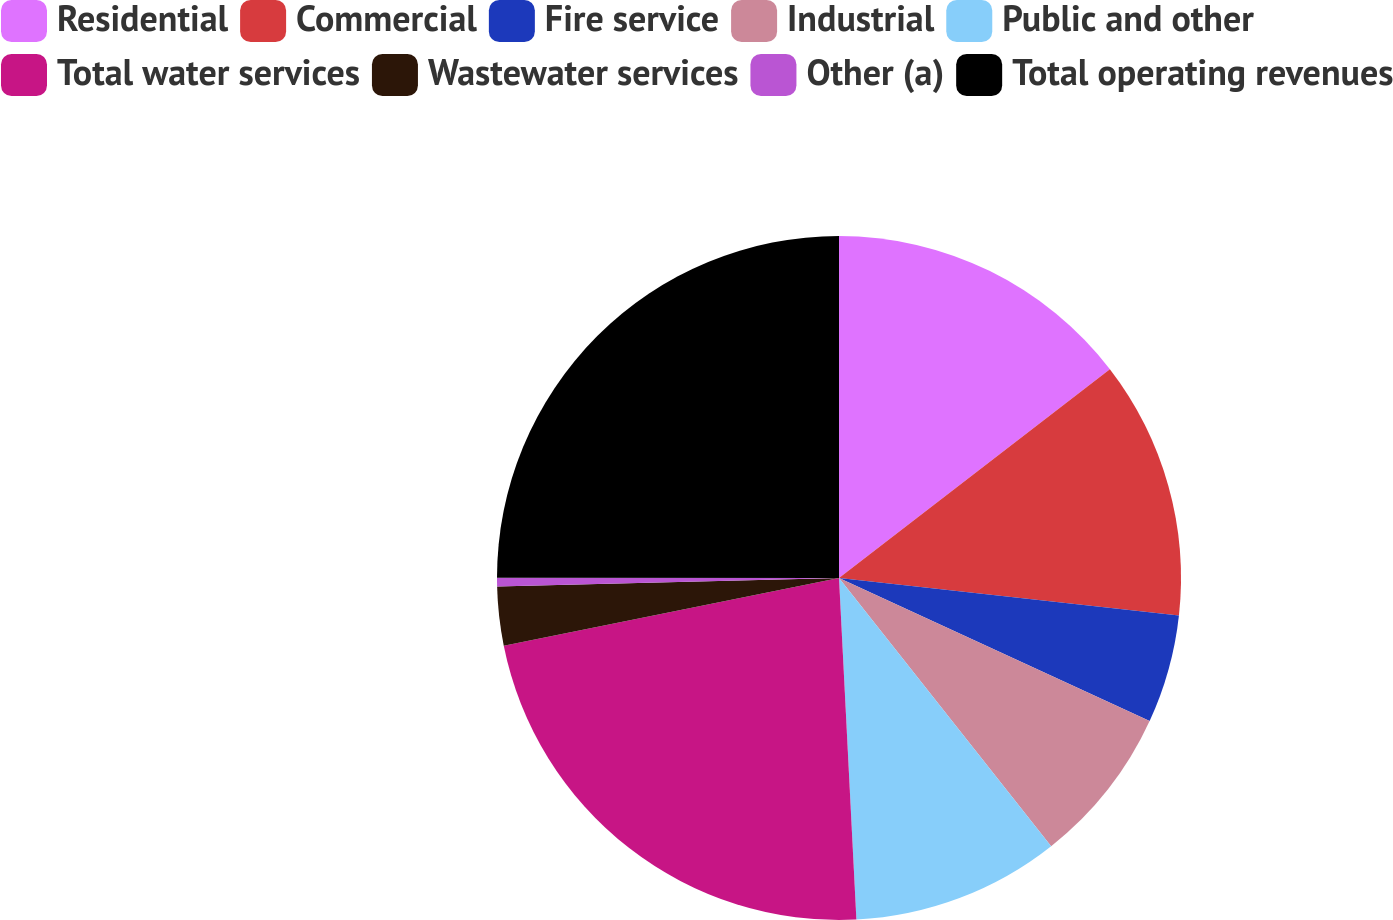Convert chart. <chart><loc_0><loc_0><loc_500><loc_500><pie_chart><fcel>Residential<fcel>Commercial<fcel>Fire service<fcel>Industrial<fcel>Public and other<fcel>Total water services<fcel>Wastewater services<fcel>Other (a)<fcel>Total operating revenues<nl><fcel>14.55%<fcel>12.2%<fcel>5.12%<fcel>7.48%<fcel>9.84%<fcel>22.64%<fcel>2.77%<fcel>0.41%<fcel>24.99%<nl></chart> 